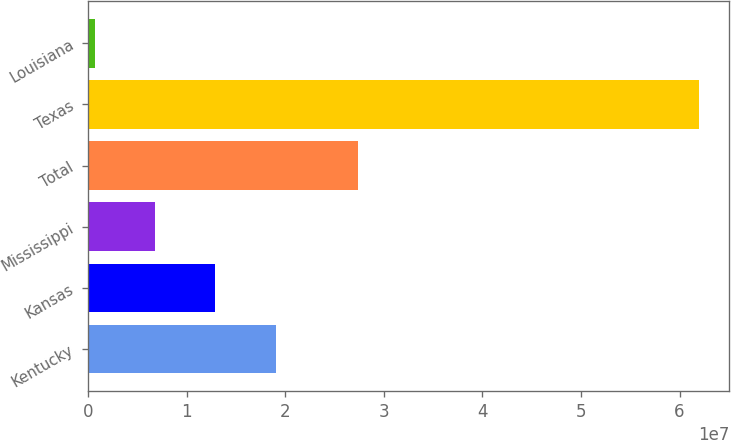<chart> <loc_0><loc_0><loc_500><loc_500><bar_chart><fcel>Kentucky<fcel>Kansas<fcel>Mississippi<fcel>Total<fcel>Texas<fcel>Louisiana<nl><fcel>1.9056e+07<fcel>1.29267e+07<fcel>6.7973e+06<fcel>2.74088e+07<fcel>6.19616e+07<fcel>667940<nl></chart> 